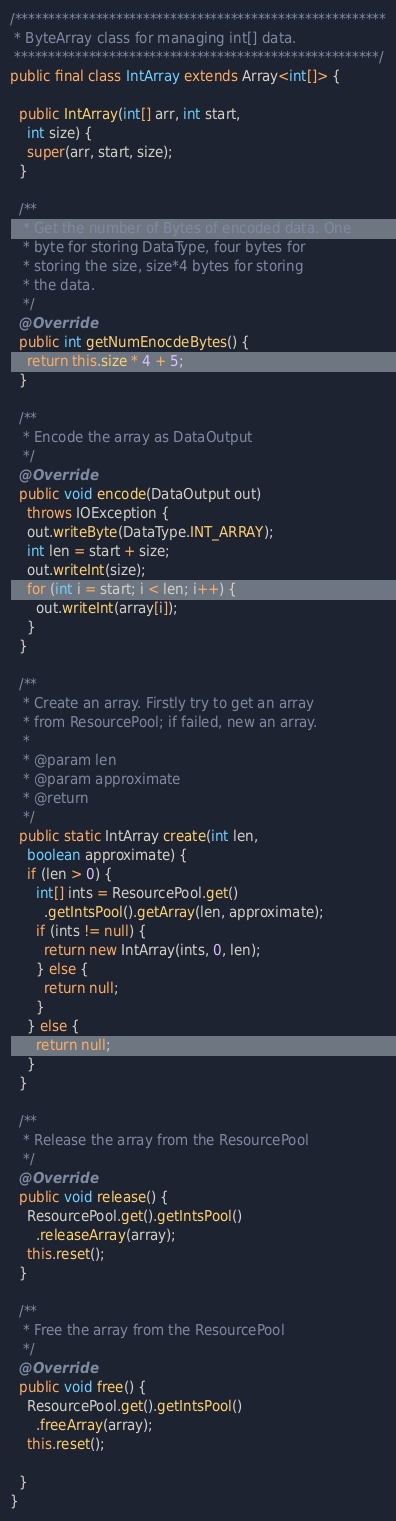Convert code to text. <code><loc_0><loc_0><loc_500><loc_500><_Java_>/*******************************************************
 * ByteArray class for managing int[] data.
 ******************************************************/
public final class IntArray extends Array<int[]> {

  public IntArray(int[] arr, int start,
    int size) {
    super(arr, start, size);
  }

  /**
   * Get the number of Bytes of encoded data. One
   * byte for storing DataType, four bytes for
   * storing the size, size*4 bytes for storing
   * the data.
   */
  @Override
  public int getNumEnocdeBytes() {
    return this.size * 4 + 5;
  }

  /**
   * Encode the array as DataOutput
   */
  @Override
  public void encode(DataOutput out)
    throws IOException {
    out.writeByte(DataType.INT_ARRAY);
    int len = start + size;
    out.writeInt(size);
    for (int i = start; i < len; i++) {
      out.writeInt(array[i]);
    }
  }

  /**
   * Create an array. Firstly try to get an array
   * from ResourcePool; if failed, new an array.
   * 
   * @param len
   * @param approximate
   * @return
   */
  public static IntArray create(int len,
    boolean approximate) {
    if (len > 0) {
      int[] ints = ResourcePool.get()
        .getIntsPool().getArray(len, approximate);
      if (ints != null) {
        return new IntArray(ints, 0, len);
      } else {
        return null;
      }
    } else {
      return null;
    }
  }

  /**
   * Release the array from the ResourcePool
   */
  @Override
  public void release() {
    ResourcePool.get().getIntsPool()
      .releaseArray(array);
    this.reset();
  }

  /**
   * Free the array from the ResourcePool
   */
  @Override
  public void free() {
    ResourcePool.get().getIntsPool()
      .freeArray(array);
    this.reset();

  }
}
</code> 